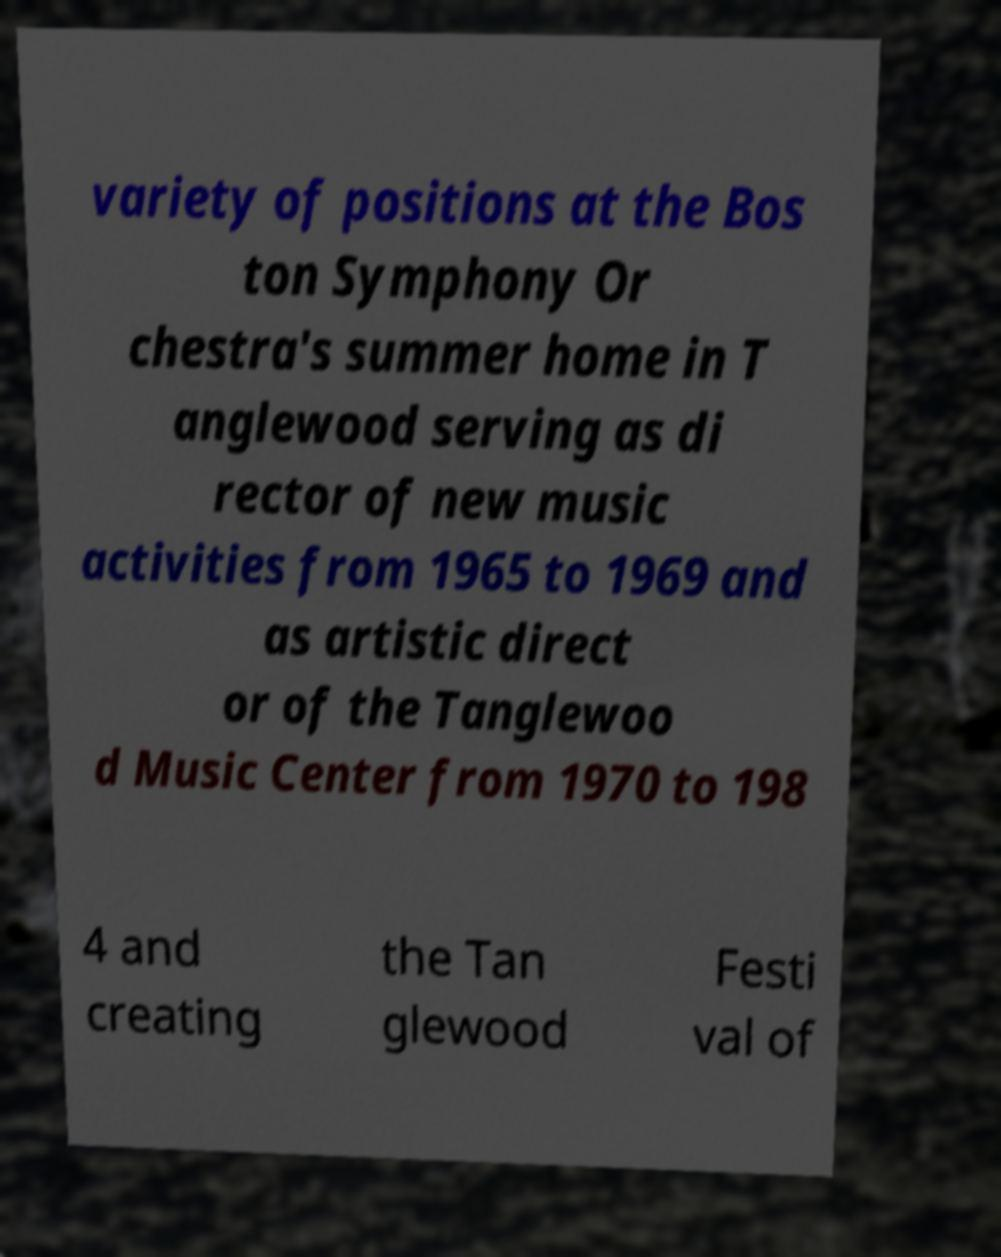Can you read and provide the text displayed in the image?This photo seems to have some interesting text. Can you extract and type it out for me? variety of positions at the Bos ton Symphony Or chestra's summer home in T anglewood serving as di rector of new music activities from 1965 to 1969 and as artistic direct or of the Tanglewoo d Music Center from 1970 to 198 4 and creating the Tan glewood Festi val of 